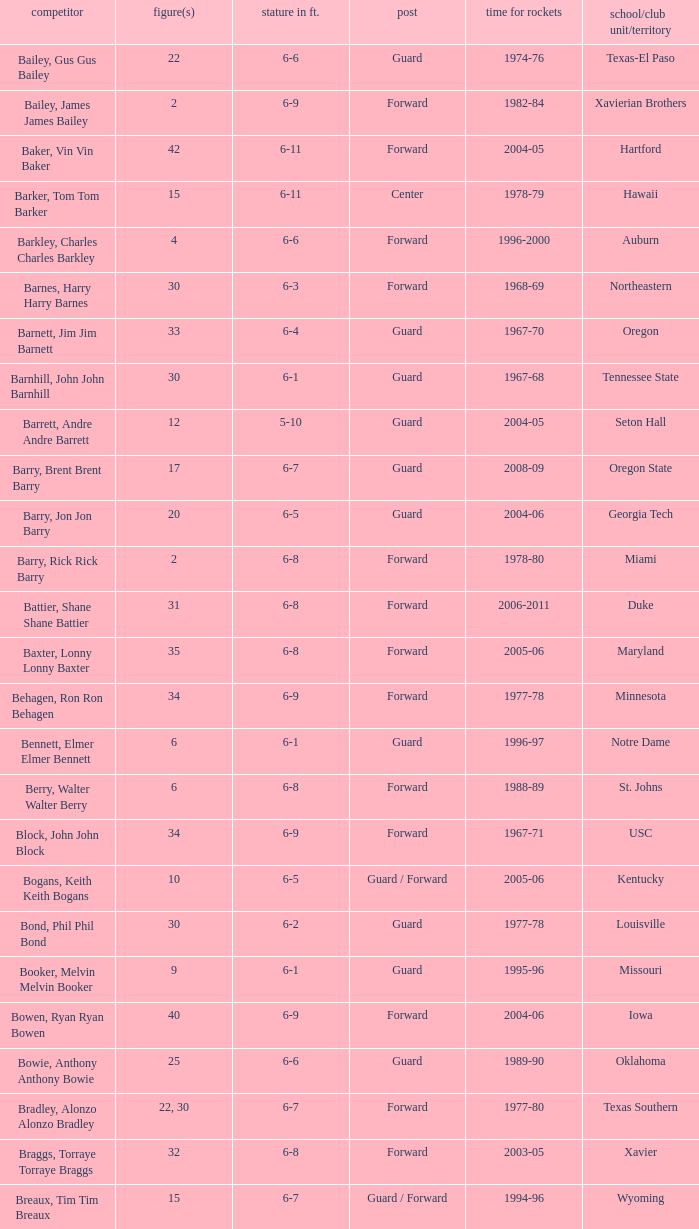What school did the forward whose number is 10 belong to? Arizona. Give me the full table as a dictionary. {'header': ['competitor', 'figure(s)', 'stature in ft.', 'post', 'time for rockets', 'school/club unit/territory'], 'rows': [['Bailey, Gus Gus Bailey', '22', '6-6', 'Guard', '1974-76', 'Texas-El Paso'], ['Bailey, James James Bailey', '2', '6-9', 'Forward', '1982-84', 'Xavierian Brothers'], ['Baker, Vin Vin Baker', '42', '6-11', 'Forward', '2004-05', 'Hartford'], ['Barker, Tom Tom Barker', '15', '6-11', 'Center', '1978-79', 'Hawaii'], ['Barkley, Charles Charles Barkley', '4', '6-6', 'Forward', '1996-2000', 'Auburn'], ['Barnes, Harry Harry Barnes', '30', '6-3', 'Forward', '1968-69', 'Northeastern'], ['Barnett, Jim Jim Barnett', '33', '6-4', 'Guard', '1967-70', 'Oregon'], ['Barnhill, John John Barnhill', '30', '6-1', 'Guard', '1967-68', 'Tennessee State'], ['Barrett, Andre Andre Barrett', '12', '5-10', 'Guard', '2004-05', 'Seton Hall'], ['Barry, Brent Brent Barry', '17', '6-7', 'Guard', '2008-09', 'Oregon State'], ['Barry, Jon Jon Barry', '20', '6-5', 'Guard', '2004-06', 'Georgia Tech'], ['Barry, Rick Rick Barry', '2', '6-8', 'Forward', '1978-80', 'Miami'], ['Battier, Shane Shane Battier', '31', '6-8', 'Forward', '2006-2011', 'Duke'], ['Baxter, Lonny Lonny Baxter', '35', '6-8', 'Forward', '2005-06', 'Maryland'], ['Behagen, Ron Ron Behagen', '34', '6-9', 'Forward', '1977-78', 'Minnesota'], ['Bennett, Elmer Elmer Bennett', '6', '6-1', 'Guard', '1996-97', 'Notre Dame'], ['Berry, Walter Walter Berry', '6', '6-8', 'Forward', '1988-89', 'St. Johns'], ['Block, John John Block', '34', '6-9', 'Forward', '1967-71', 'USC'], ['Bogans, Keith Keith Bogans', '10', '6-5', 'Guard / Forward', '2005-06', 'Kentucky'], ['Bond, Phil Phil Bond', '30', '6-2', 'Guard', '1977-78', 'Louisville'], ['Booker, Melvin Melvin Booker', '9', '6-1', 'Guard', '1995-96', 'Missouri'], ['Bowen, Ryan Ryan Bowen', '40', '6-9', 'Forward', '2004-06', 'Iowa'], ['Bowie, Anthony Anthony Bowie', '25', '6-6', 'Guard', '1989-90', 'Oklahoma'], ['Bradley, Alonzo Alonzo Bradley', '22, 30', '6-7', 'Forward', '1977-80', 'Texas Southern'], ['Braggs, Torraye Torraye Braggs', '32', '6-8', 'Forward', '2003-05', 'Xavier'], ['Breaux, Tim Tim Breaux', '15', '6-7', 'Guard / Forward', '1994-96', 'Wyoming'], ['Britt, Tyrone Tyrone Britt', '31', '6-4', 'Guard', '1967-68', 'Johnson C. Smith'], ['Brooks, Aaron Aaron Brooks', '0', '6-0', 'Guard', '2007-2011, 2013', 'Oregon'], ['Brooks, Scott Scott Brooks', '1', '5-11', 'Guard', '1992-95', 'UC-Irvine'], ['Brown, Chucky Chucky Brown', '52', '6-8', 'Forward', '1994-96', 'North Carolina'], ['Brown, Tony Tony Brown', '35', '6-6', 'Forward', '1988-89', 'Arkansas'], ['Brown, Tierre Tierre Brown', '10', '6-2', 'Guard', '2001-02', 'McNesse State'], ['Brunson, Rick Rick Brunson', '9', '6-4', 'Guard', '2005-06', 'Temple'], ['Bryant, Joe Joe Bryant', '22', '6-9', 'Forward / Guard', '1982-83', 'LaSalle'], ['Bryant, Mark Mark Bryant', '2', '6-9', 'Forward', '1995-96', 'Seton Hall'], ['Budinger, Chase Chase Budinger', '10', '6-7', 'Forward', '2009-2012', 'Arizona'], ['Bullard, Matt Matt Bullard', '50', '6-10', 'Forward', '1990-94, 1996-2001', 'Iowa']]} 